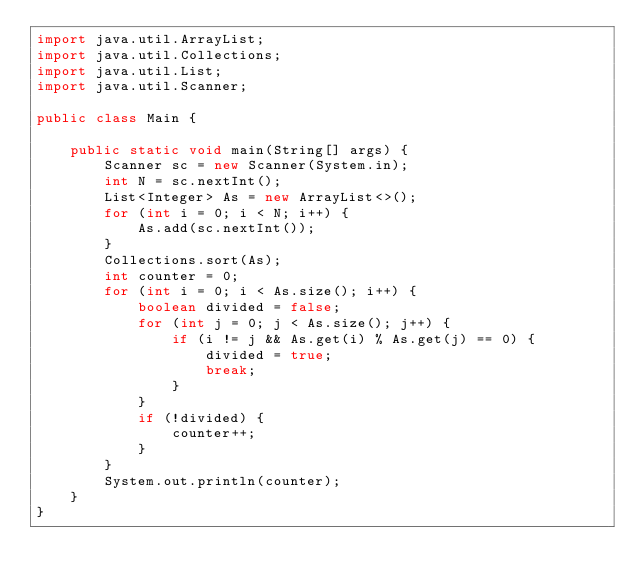<code> <loc_0><loc_0><loc_500><loc_500><_Java_>import java.util.ArrayList;
import java.util.Collections;
import java.util.List;
import java.util.Scanner;

public class Main {

    public static void main(String[] args) {
        Scanner sc = new Scanner(System.in);
        int N = sc.nextInt();
        List<Integer> As = new ArrayList<>();
        for (int i = 0; i < N; i++) {
            As.add(sc.nextInt());
        }
        Collections.sort(As);
        int counter = 0;
        for (int i = 0; i < As.size(); i++) {
            boolean divided = false;
            for (int j = 0; j < As.size(); j++) {
                if (i != j && As.get(i) % As.get(j) == 0) {
                    divided = true;
                    break;
                }
            }
            if (!divided) {
                counter++;
            }
        }
        System.out.println(counter);
    }
}</code> 